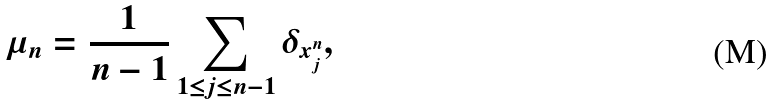<formula> <loc_0><loc_0><loc_500><loc_500>\mu _ { n } = \frac { 1 } { n - 1 } \sum _ { 1 \leq j \leq n - 1 } \delta _ { x _ { j } ^ { n } } ,</formula> 